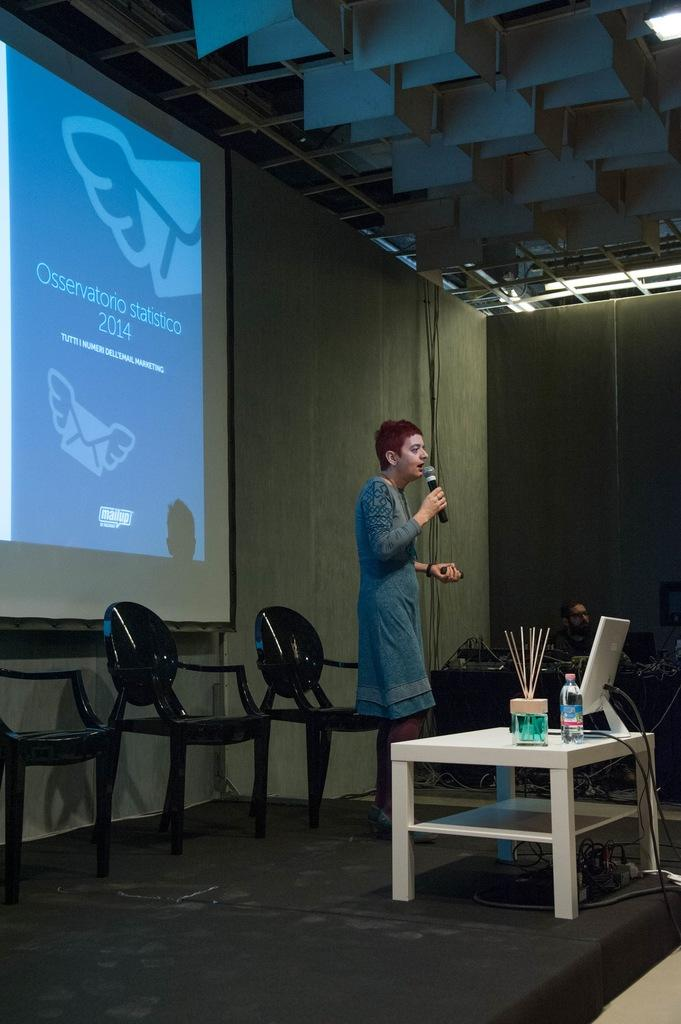<image>
Render a clear and concise summary of the photo. A woman speaks during an Osservatorio statistico 2014 presentation. 